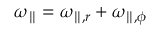Convert formula to latex. <formula><loc_0><loc_0><loc_500><loc_500>\omega _ { \| } = \omega _ { \| , r } + \omega _ { \| , \phi }</formula> 